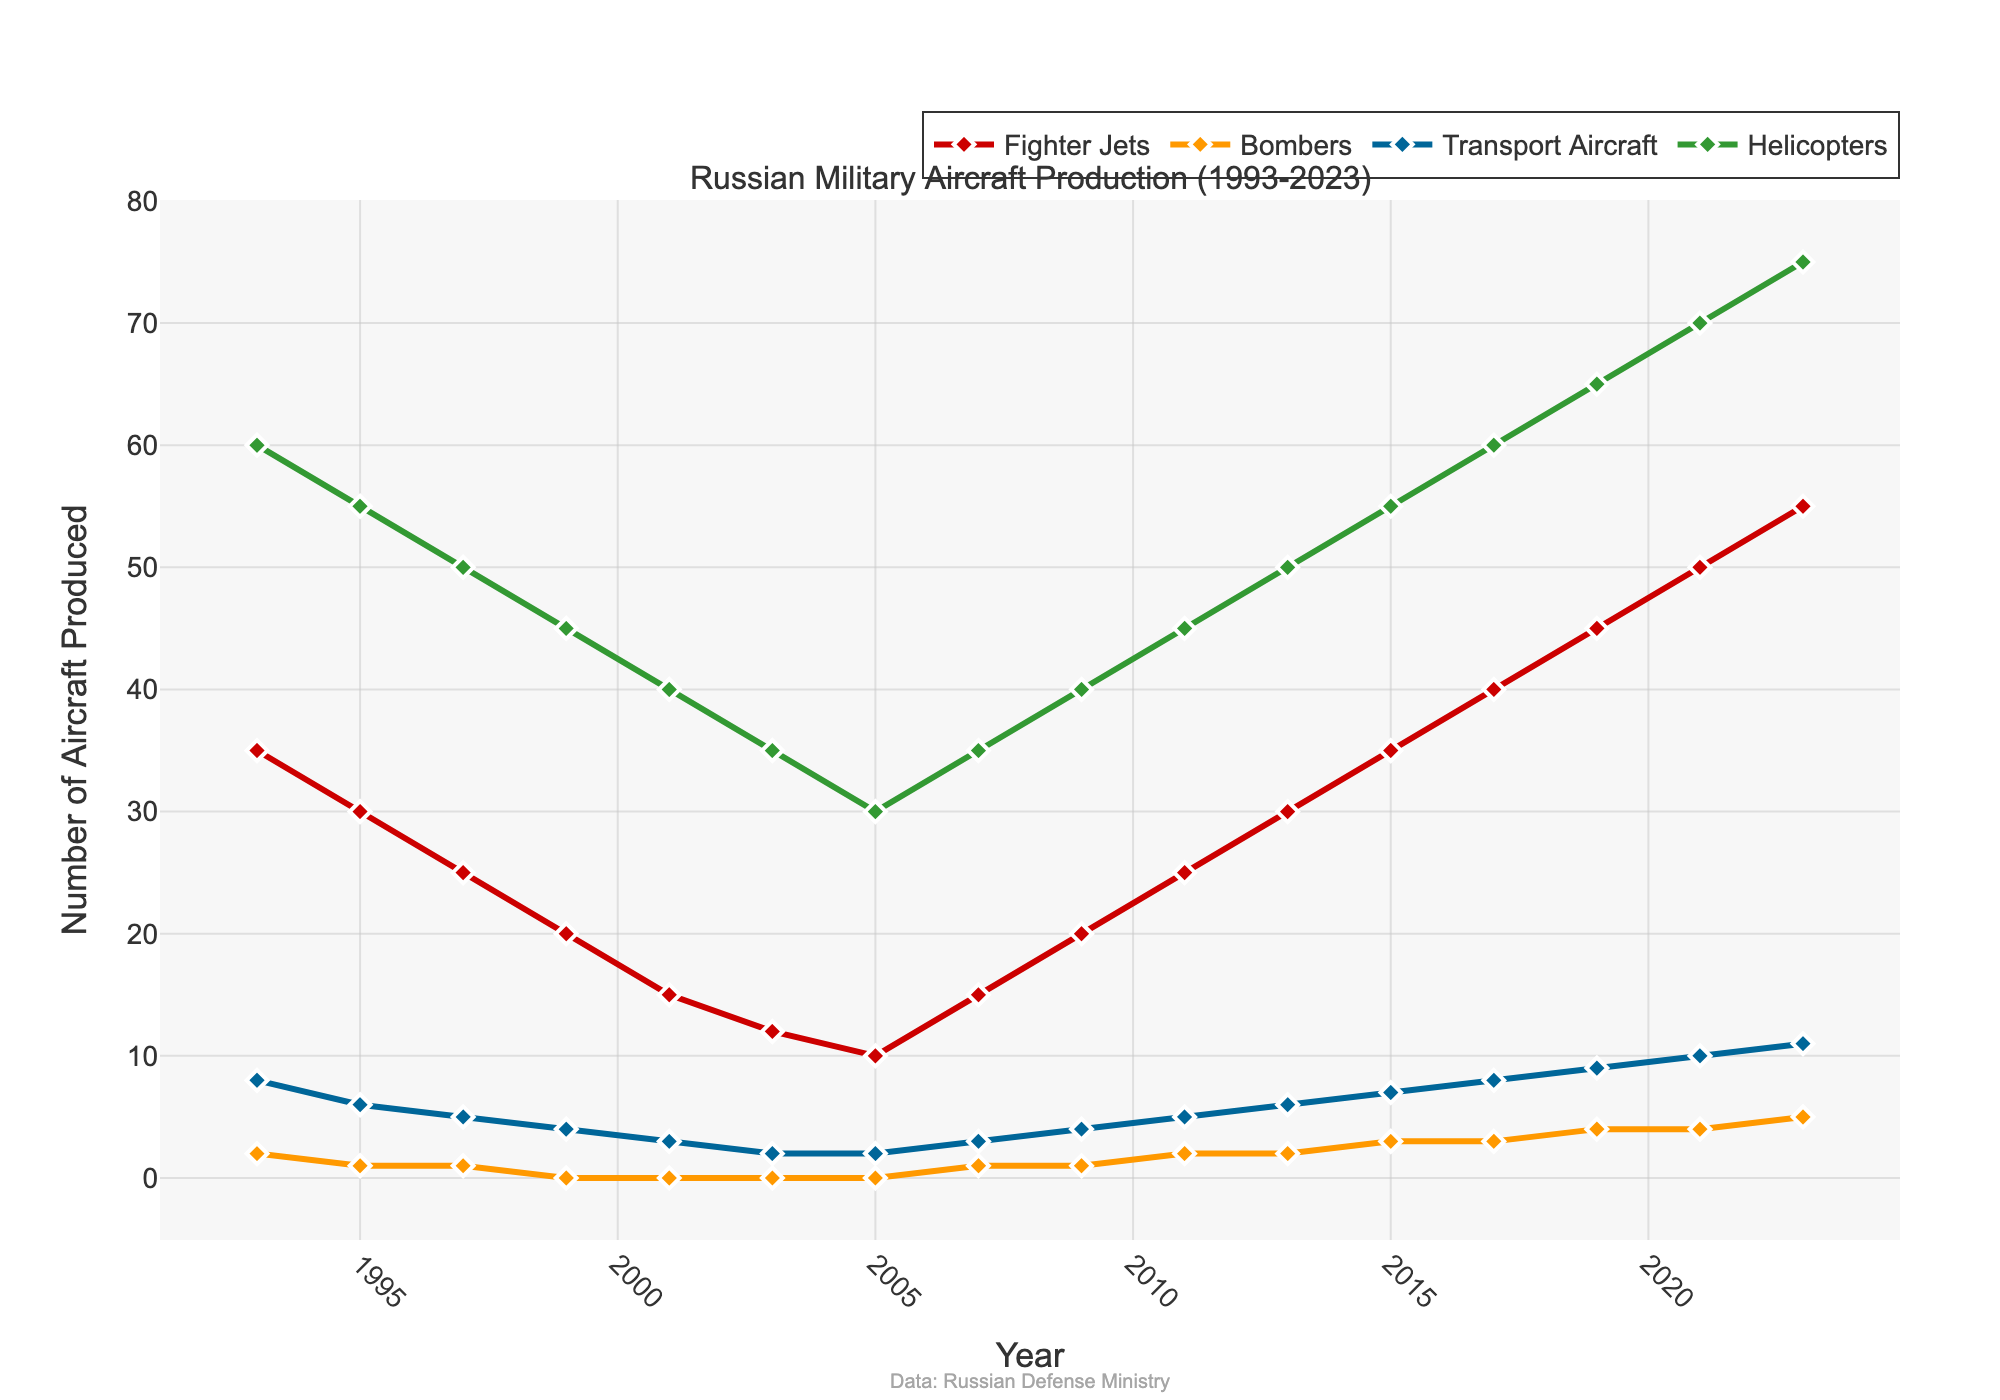Which aircraft type saw the highest production in 2023? In the figure, notice the height of the lines for each year. In 2023, the line representing Helicopters reaches the highest point.
Answer: Helicopters How did the production of Fighter Jets change from 1993 to 2003? In 1993, Fighter Jets production was 35 units. By 2003, it dropped to 12 units. The change represents a decrease.
Answer: Decreased Compare the production of Bombers and Transport Aircraft in 1999. Which was produced more? In 1999, the production for Bombers was 0 and for Transport Aircraft was 4. Since 4 is greater than 0, more Transport Aircraft were produced.
Answer: Transport Aircraft What is the trend in Helicopters production from 2003 to 2023? The Helicopters production line shows a steady increase from 35 units in 2003 to 75 units in 2023.
Answer: Increasing What is the average number of Fighter Jets produced between 1993 and 2023? To find the average, sum the production numbers (35+30+25+20+15+12+10+15+20+25+30+35+40+45+50+55) and divide by the number of years (16). The sum is 452, so the average is 452/16.
Answer: 28.25 Calculate the sum of Bomber production from 1993 to 2023. Add up the production numbers for Bombers over the selected years (2+1+1+0+0+0+0+1+1+2+2+3+3+4+4+5). The total sum is 29.
Answer: 29 Which aircraft type shows the least variability in production numbers throughout the period? Comparing the fluctuations in the plot lines reveals that Bombers show the least variability, with figures only ranging from 0 to 5.
Answer: Bombers Compare the production of Transport Aircraft in 1997 and 2023. How much did it increase? The production in 1997 was 5 units, and in 2023, it was 11 units. The increase is 11 - 5 = 6 units.
Answer: 6 units Between which two consecutive years does the largest increase in Fighter Jets production occur? Observing the Fighter Jets line, the largest increase occurs between 2019 and 2021, where production jumped from 45 to 50 units, an increase of 5 units.
Answer: 2019-2021 Which aircraft type had declining production from 1993 to 2005? Observing the lines, Fighter Jets show a decline from 35 in 1993 to 10 in 2005.
Answer: Fighter Jets 